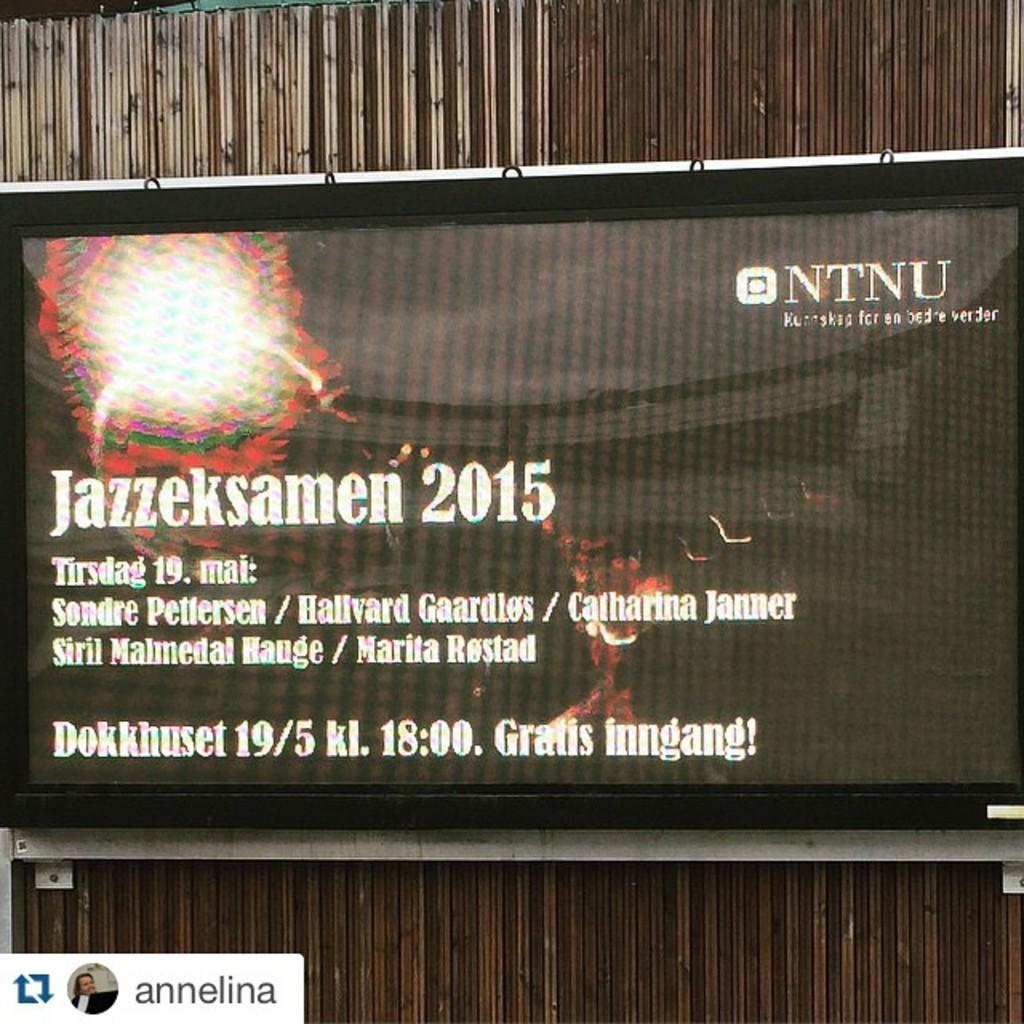<image>
Present a compact description of the photo's key features. A screen displays information and details for Jazzeksamen 2015. 